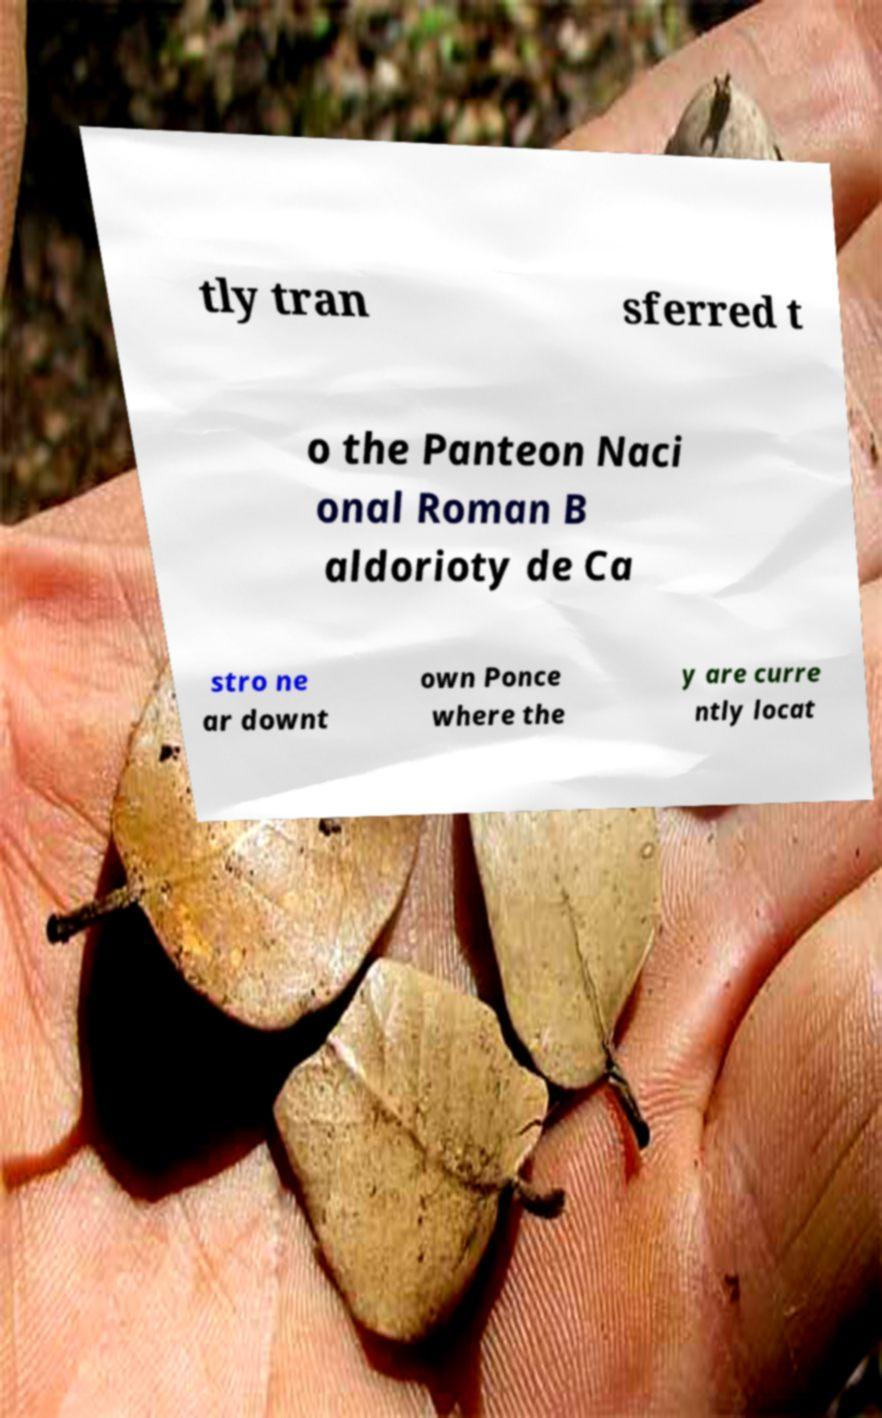What messages or text are displayed in this image? I need them in a readable, typed format. tly tran sferred t o the Panteon Naci onal Roman B aldorioty de Ca stro ne ar downt own Ponce where the y are curre ntly locat 